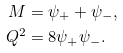<formula> <loc_0><loc_0><loc_500><loc_500>M & = \psi _ { + } + \psi _ { - } , \\ Q ^ { 2 } & = 8 \psi _ { + } \psi _ { - } .</formula> 